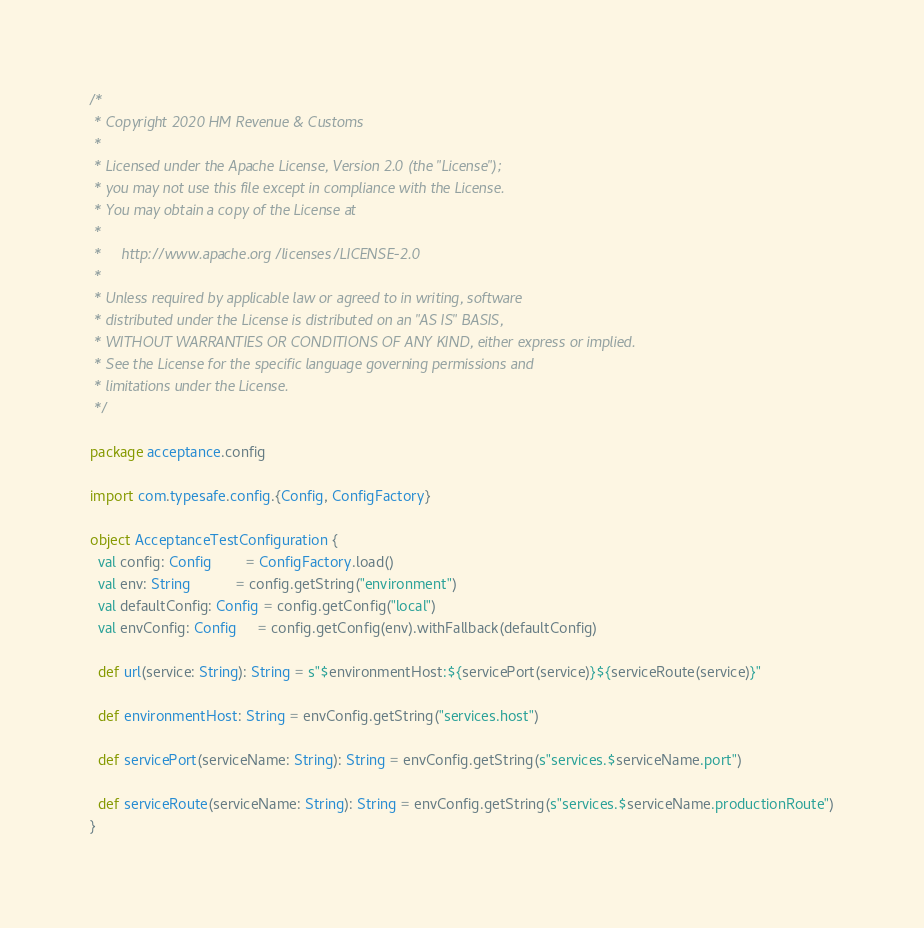<code> <loc_0><loc_0><loc_500><loc_500><_Scala_>/*
 * Copyright 2020 HM Revenue & Customs
 *
 * Licensed under the Apache License, Version 2.0 (the "License");
 * you may not use this file except in compliance with the License.
 * You may obtain a copy of the License at
 *
 *     http://www.apache.org/licenses/LICENSE-2.0
 *
 * Unless required by applicable law or agreed to in writing, software
 * distributed under the License is distributed on an "AS IS" BASIS,
 * WITHOUT WARRANTIES OR CONDITIONS OF ANY KIND, either express or implied.
 * See the License for the specific language governing permissions and
 * limitations under the License.
 */

package acceptance.config

import com.typesafe.config.{Config, ConfigFactory}

object AcceptanceTestConfiguration {
  val config: Config        = ConfigFactory.load()
  val env: String           = config.getString("environment")
  val defaultConfig: Config = config.getConfig("local")
  val envConfig: Config     = config.getConfig(env).withFallback(defaultConfig)

  def url(service: String): String = s"$environmentHost:${servicePort(service)}${serviceRoute(service)}"

  def environmentHost: String = envConfig.getString("services.host")

  def servicePort(serviceName: String): String = envConfig.getString(s"services.$serviceName.port")

  def serviceRoute(serviceName: String): String = envConfig.getString(s"services.$serviceName.productionRoute")
}
</code> 